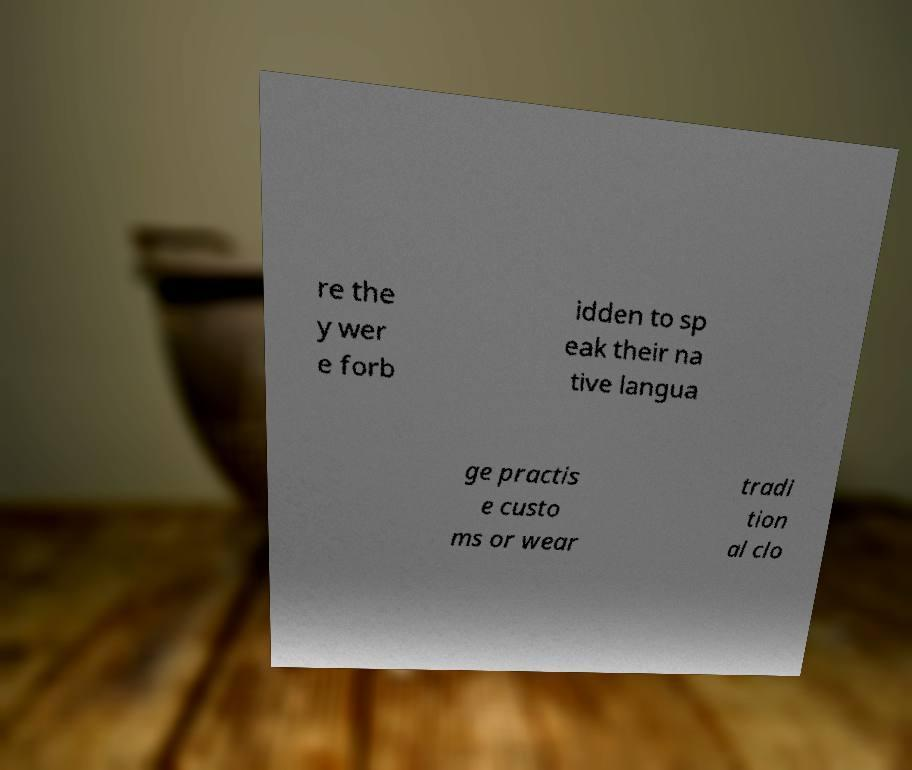Can you read and provide the text displayed in the image?This photo seems to have some interesting text. Can you extract and type it out for me? re the y wer e forb idden to sp eak their na tive langua ge practis e custo ms or wear tradi tion al clo 